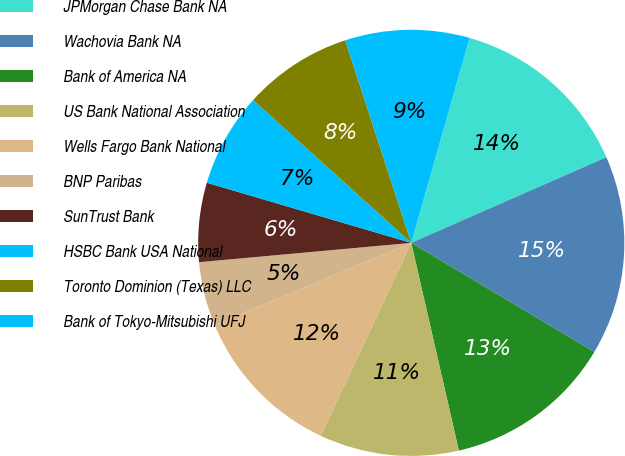Convert chart. <chart><loc_0><loc_0><loc_500><loc_500><pie_chart><fcel>JPMorgan Chase Bank NA<fcel>Wachovia Bank NA<fcel>Bank of America NA<fcel>US Bank National Association<fcel>Wells Fargo Bank National<fcel>BNP Paribas<fcel>SunTrust Bank<fcel>HSBC Bank USA National<fcel>Toronto Dominion (Texas) LLC<fcel>Bank of Tokyo-Mitsubishi UFJ<nl><fcel>14.0%<fcel>15.14%<fcel>12.86%<fcel>10.57%<fcel>11.71%<fcel>4.86%<fcel>6.0%<fcel>7.14%<fcel>8.29%<fcel>9.43%<nl></chart> 